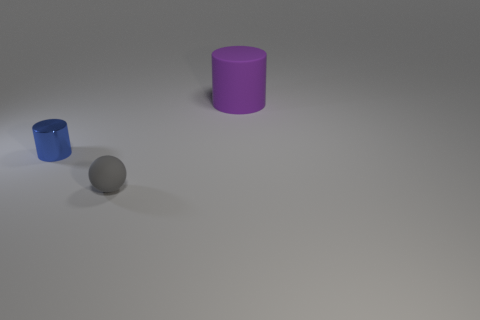Subtract 1 cylinders. How many cylinders are left? 1 Add 1 small blue metal objects. How many small blue metal objects are left? 2 Add 1 large rubber cylinders. How many large rubber cylinders exist? 2 Add 2 small gray balls. How many objects exist? 5 Subtract 0 purple spheres. How many objects are left? 3 Subtract all balls. How many objects are left? 2 Subtract all cyan cylinders. Subtract all gray spheres. How many cylinders are left? 2 Subtract all purple cylinders. How many red balls are left? 0 Subtract all small gray balls. Subtract all tiny gray rubber spheres. How many objects are left? 1 